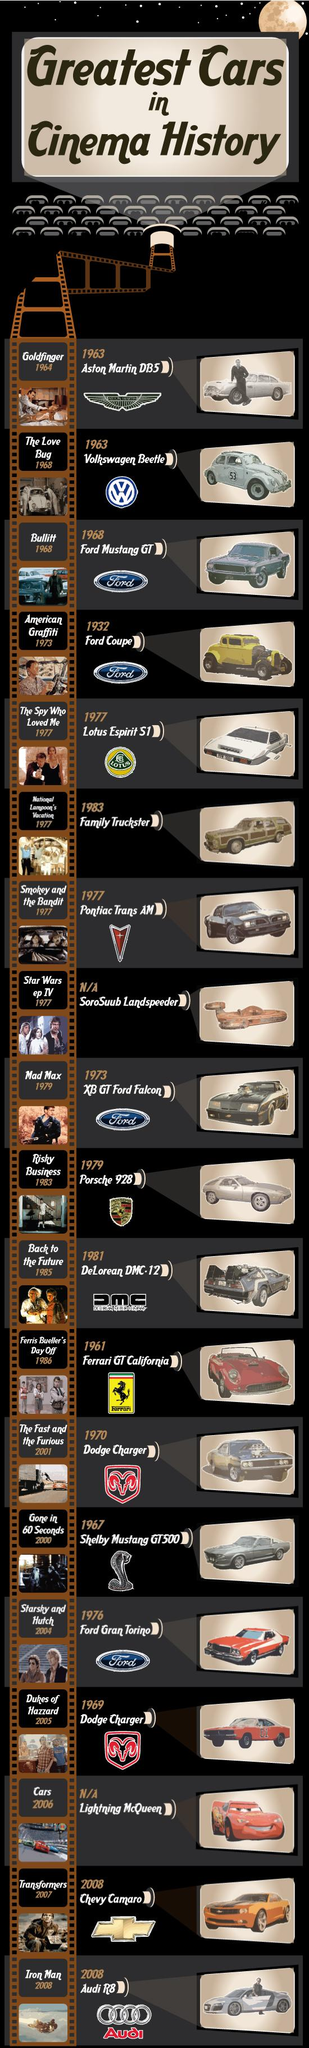Specify some key components in this picture. The Ford Coupe is either yellow or grey in color. The Dodge Charger has been featured in several movies, including "The Dukes of Hazzard" in 2005 and "The Fast and the Furious" in 2001. The text located below the horse in the Ferrari logo is written in Latin and translates to 'Ferrari.' The Volkswagen Beetle has a number written on it that is 53. The Audi R8 was featured in the 2008 movie "Iron Man," where it was driven by the film's lead character, Tony Stark, played by actor Robert Downey Jr. 